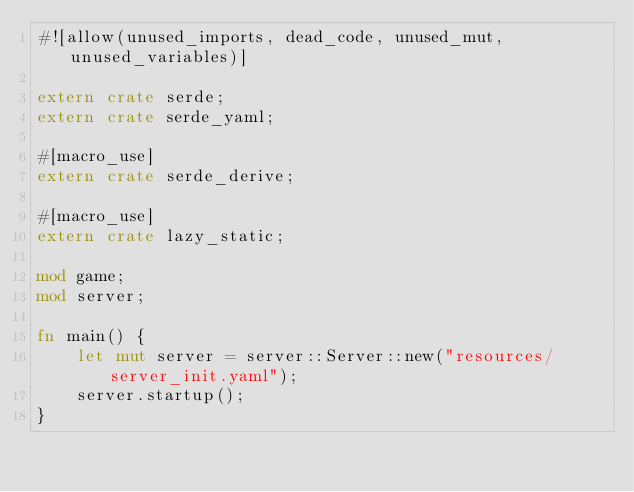<code> <loc_0><loc_0><loc_500><loc_500><_Rust_>#![allow(unused_imports, dead_code, unused_mut, unused_variables)]

extern crate serde;
extern crate serde_yaml;

#[macro_use]
extern crate serde_derive;

#[macro_use]
extern crate lazy_static;

mod game;
mod server;

fn main() {
    let mut server = server::Server::new("resources/server_init.yaml");
    server.startup();
}


</code> 